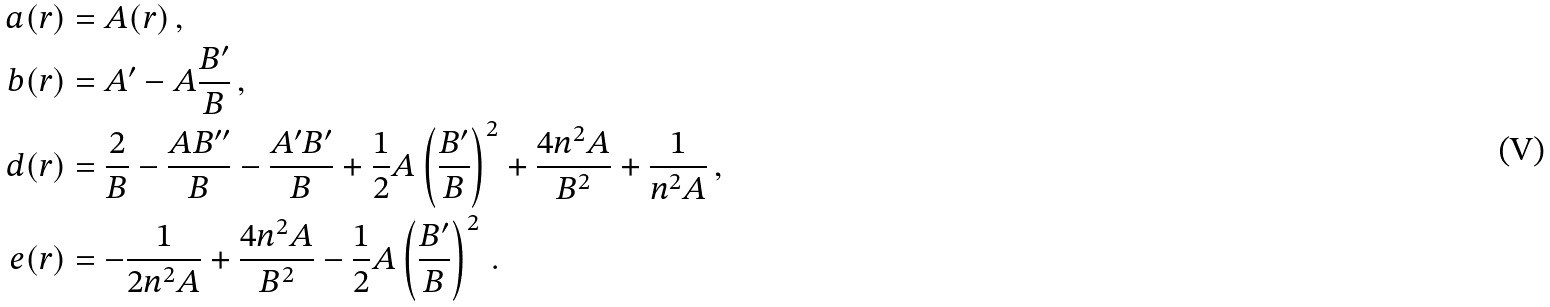<formula> <loc_0><loc_0><loc_500><loc_500>a ( r ) & = A ( r ) \, , \\ b ( r ) & = A ^ { \prime } - A \frac { B ^ { \prime } } { B } \, , \\ d ( r ) & = \frac { 2 } { B } - \frac { A B ^ { \prime \prime } } { B } - \frac { A ^ { \prime } B ^ { \prime } } { B } + \frac { 1 } { 2 } A \left ( \frac { B ^ { \prime } } { B } \right ) ^ { 2 } + \frac { 4 n ^ { 2 } A } { B ^ { 2 } } + \frac { 1 } { n ^ { 2 } A } \, , \\ e ( r ) & = - \frac { 1 } { 2 n ^ { 2 } A } + \frac { 4 n ^ { 2 } A } { B ^ { 2 } } - \frac { 1 } { 2 } A \left ( \frac { B ^ { \prime } } { B } \right ) ^ { 2 } \, .</formula> 